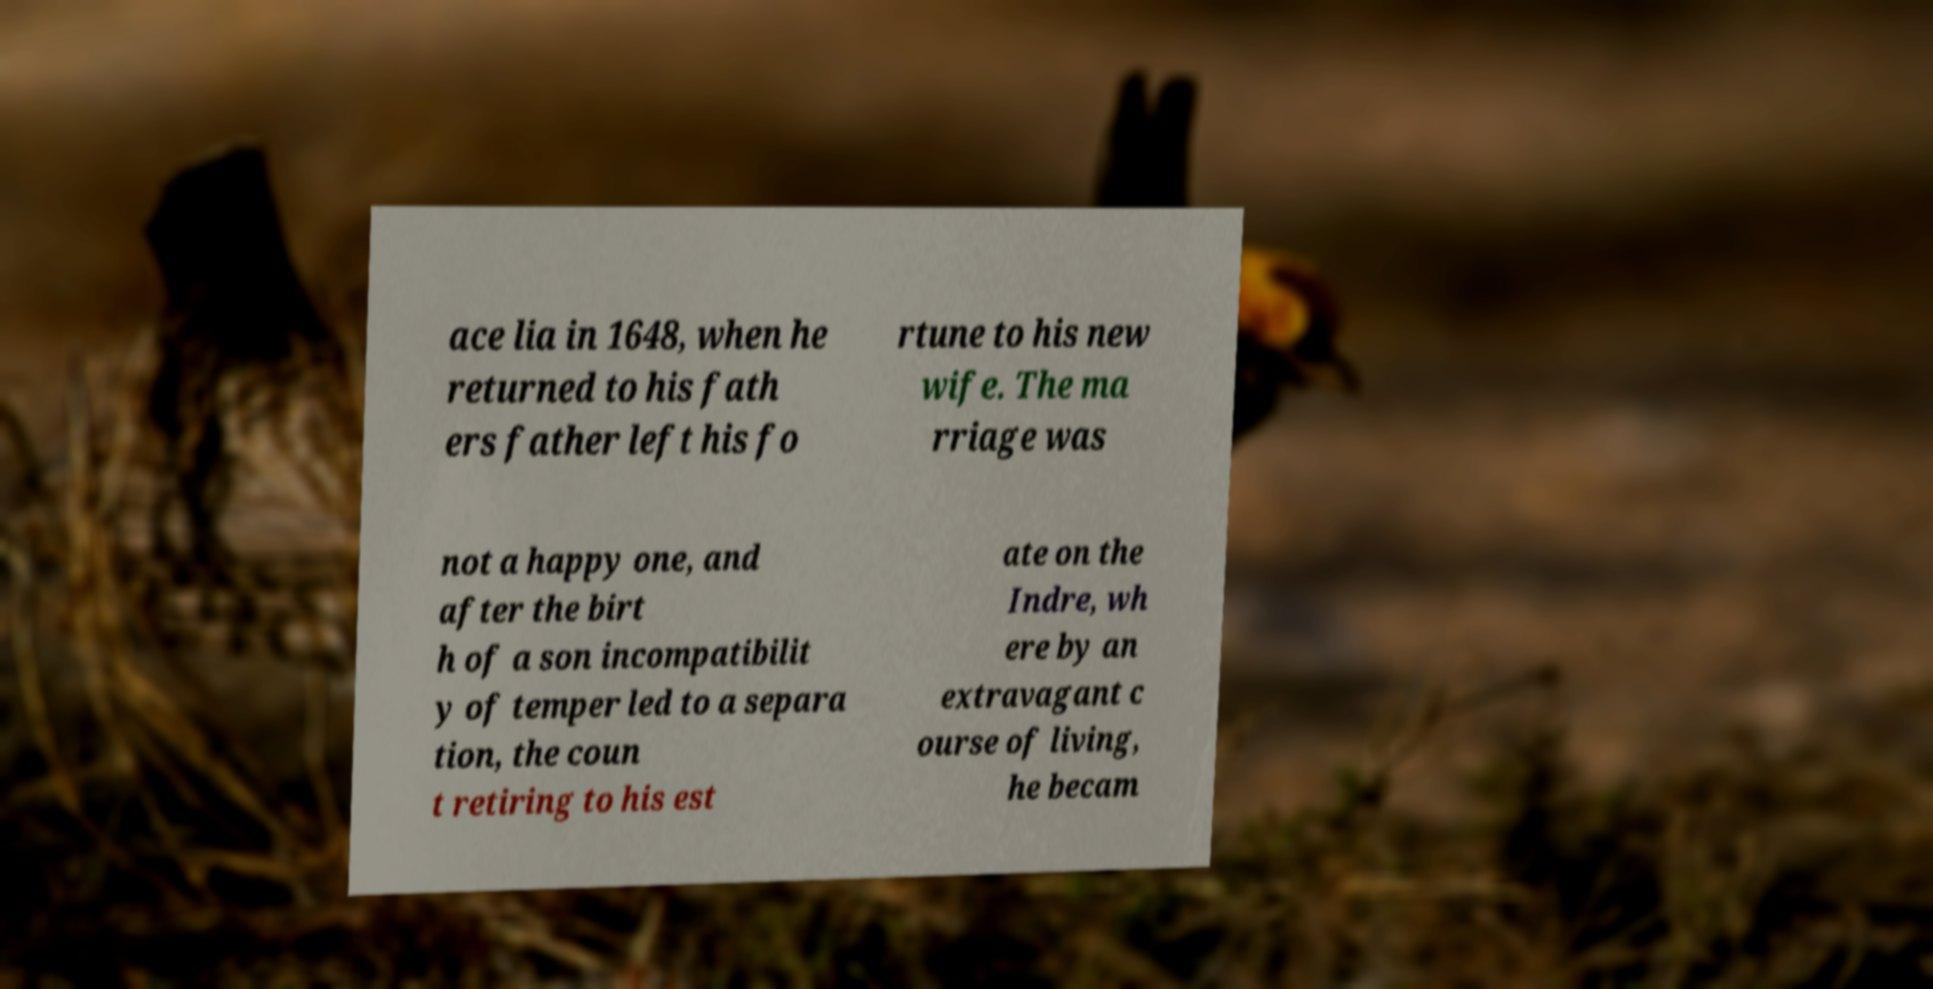For documentation purposes, I need the text within this image transcribed. Could you provide that? ace lia in 1648, when he returned to his fath ers father left his fo rtune to his new wife. The ma rriage was not a happy one, and after the birt h of a son incompatibilit y of temper led to a separa tion, the coun t retiring to his est ate on the Indre, wh ere by an extravagant c ourse of living, he becam 